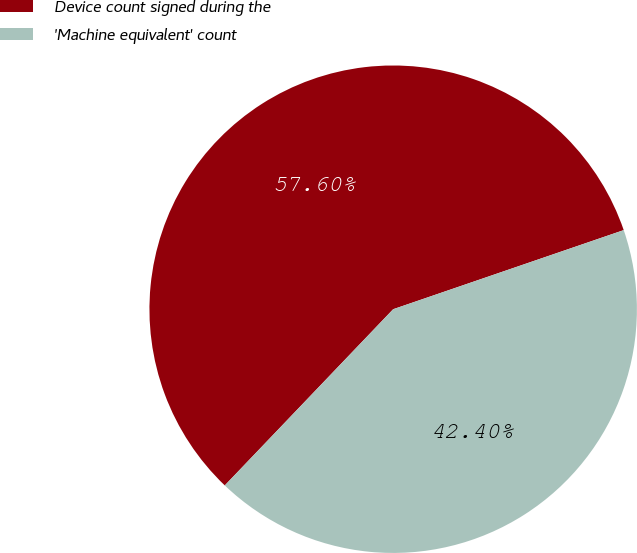<chart> <loc_0><loc_0><loc_500><loc_500><pie_chart><fcel>Device count signed during the<fcel>'Machine equivalent' count<nl><fcel>57.6%<fcel>42.4%<nl></chart> 